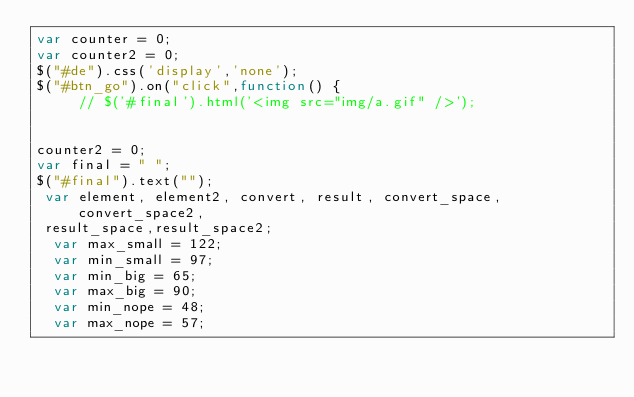Convert code to text. <code><loc_0><loc_0><loc_500><loc_500><_JavaScript_>var counter = 0;
var counter2 = 0;
$("#de").css('display','none');
$("#btn_go").on("click",function() {
     // $('#final').html('<img src="img/a.gif" />');


counter2 = 0;
var final = " ";
$("#final").text("");
 var element, element2, convert, result, convert_space,convert_space2,
 result_space,result_space2;
  var max_small = 122;
  var min_small = 97;
  var min_big = 65;
  var max_big = 90;
  var min_nope = 48;
  var max_nope = 57;

    


</code> 